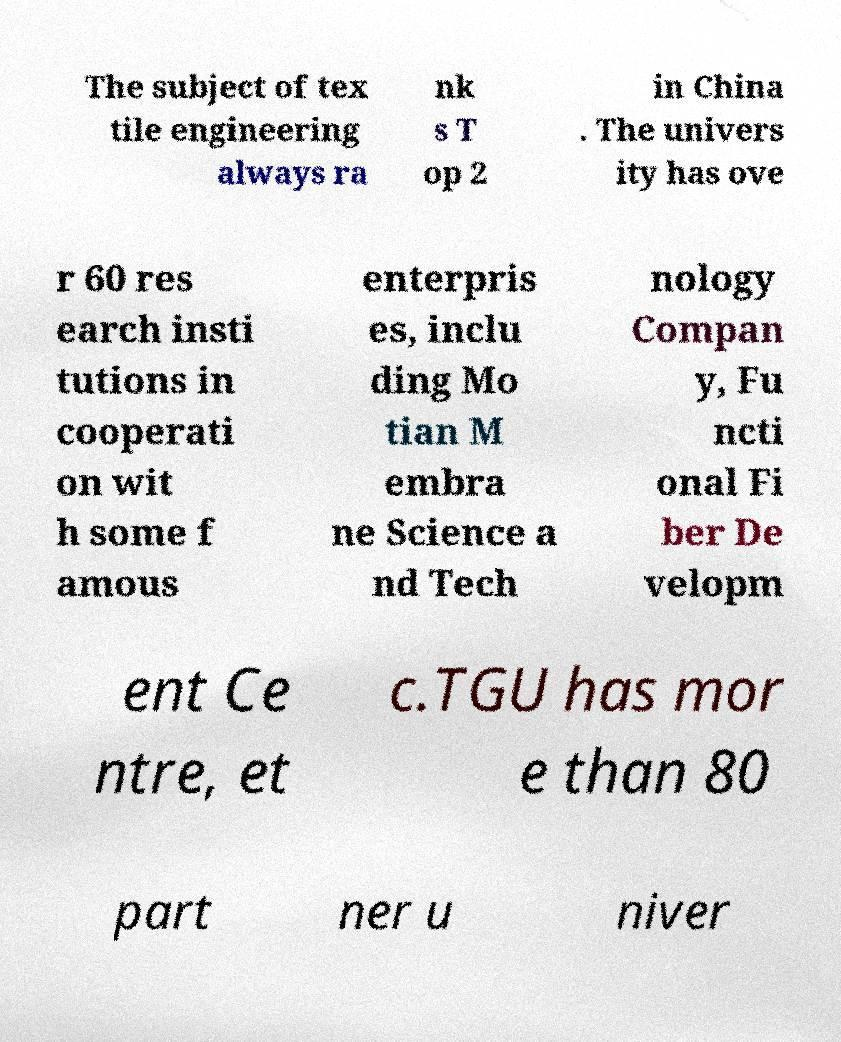Can you read and provide the text displayed in the image?This photo seems to have some interesting text. Can you extract and type it out for me? The subject of tex tile engineering always ra nk s T op 2 in China . The univers ity has ove r 60 res earch insti tutions in cooperati on wit h some f amous enterpris es, inclu ding Mo tian M embra ne Science a nd Tech nology Compan y, Fu ncti onal Fi ber De velopm ent Ce ntre, et c.TGU has mor e than 80 part ner u niver 